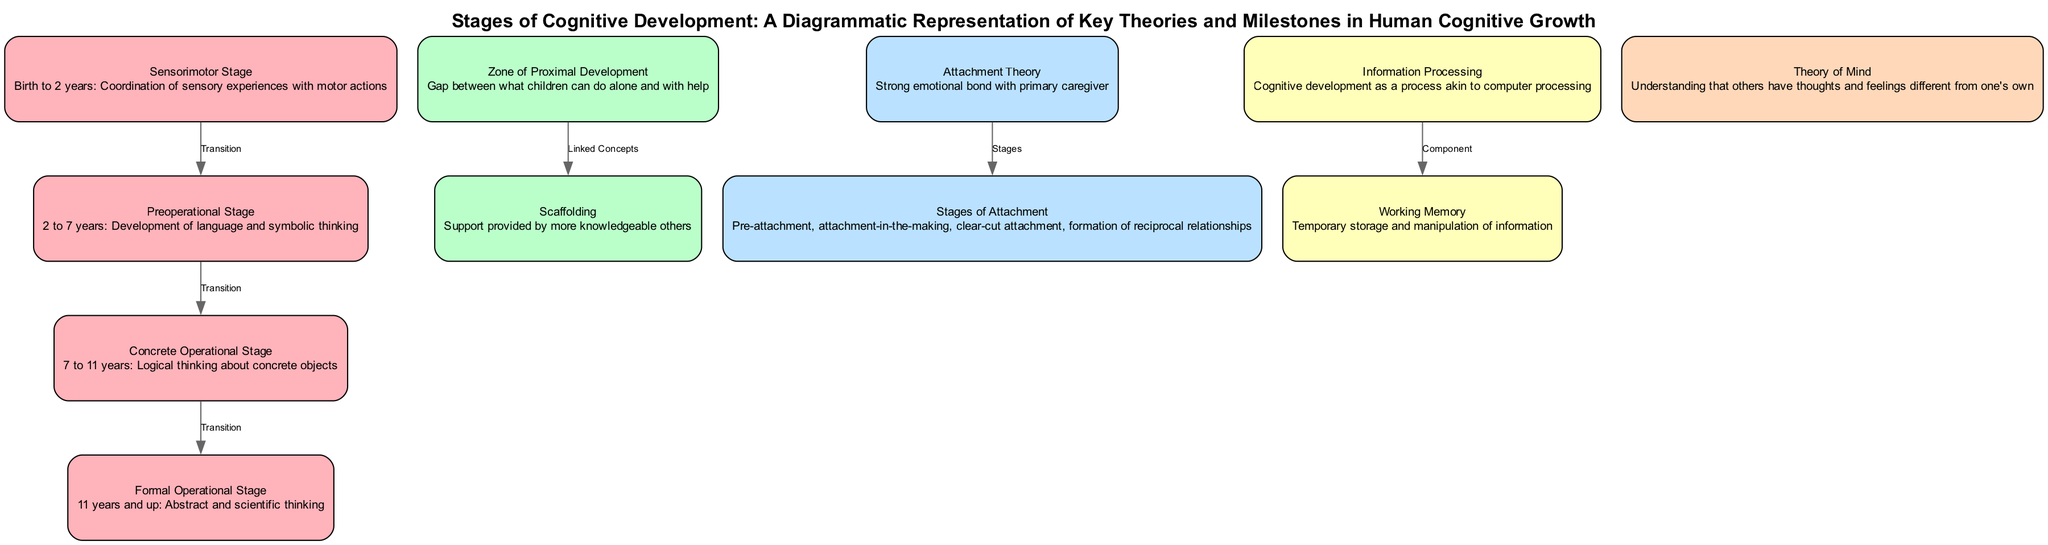What is the age range for the Sensorimotor Stage? The Sensorimotor Stage in the diagram is labeled as covering "Birth to 2 years." This information is found directly within the description of the Sensorimotor Stage node.
Answer: Birth to 2 years Which theory is associated with the Concrete Operational Stage? The Concrete Operational Stage is associated with "Piaget's Cognitive Development" as indicated by the theory label directly beneath the description of that stage.
Answer: Piaget's Cognitive Development How many stages of attachment are listed? The diagram outlines four stages under the "Stages of Attachment" node: Pre-attachment, attachment-in-the-making, clear-cut attachment, and formation of reciprocal relationships. Counting these provides a total of four stages.
Answer: Four What concept is linked to the Zone of Proximal Development? The diagram shows that "Scaffolding" is a concept linked to the Zone of Proximal Development through the edge labeled "Linked Concepts." This indicates the relationship between these two ideas in Vygotsky's theory.
Answer: Scaffolding What transitions occur between the stages in Piaget's framework? The diagram outlines a sequential flow where transitions occur from the Sensorimotor Stage to the Preoperational Stage, then to the Concrete Operational Stage, and finally to the Formal Operational Stage. To summarize, these transitions make a pathway of progression through Piaget's stages of development.
Answer: Sensorimotor to Preoperational to Concrete Operational to Formal Operational How does the information processing theory characterize cognitive development? The Information Processing Theory represented in the diagram compares cognitive development to "a process akin to computer processing." This characterizes cognitive growth as a structured, systematic operation of information handling.
Answer: A process akin to computer processing What is the key feature of Working Memory as depicted in the diagram? The Working Memory node in the diagram describes it as the "Temporary storage and manipulation of information," highlighting its role in cognitive functions. This concise definition encapsulates the essence of what Working Memory does.
Answer: Temporary storage and manipulation of information How are the stages of cognitive development organized in the diagram? The stages of cognitive development are organized hierarchically, from the Sensorimotor Stage to the Formal Operational Stage, illustrating a clear progression in cognitive capabilities as age increases within Piaget's framework. This organization reflects the developmental milestones adults expect as children grow.
Answer: Hierarchically from Sensorimotor to Formal Operational 